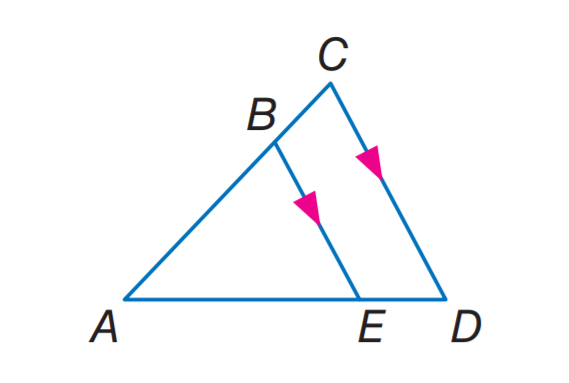Answer the mathemtical geometry problem and directly provide the correct option letter.
Question: If A B = 6, B C = 4, and A E = 9, find E D.
Choices: A: 4 B: 6 C: 9 D: 12 B 